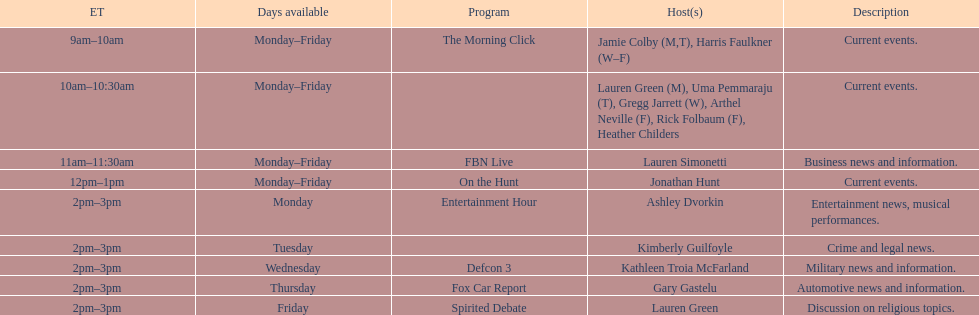How many shows have just one host each day? 7. 